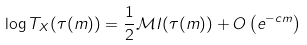<formula> <loc_0><loc_0><loc_500><loc_500>\log T _ { X } ( \tau ( m ) ) = \frac { 1 } { 2 } \mathcal { M } I ( \tau ( m ) ) + O \left ( e ^ { - c m } \right )</formula> 